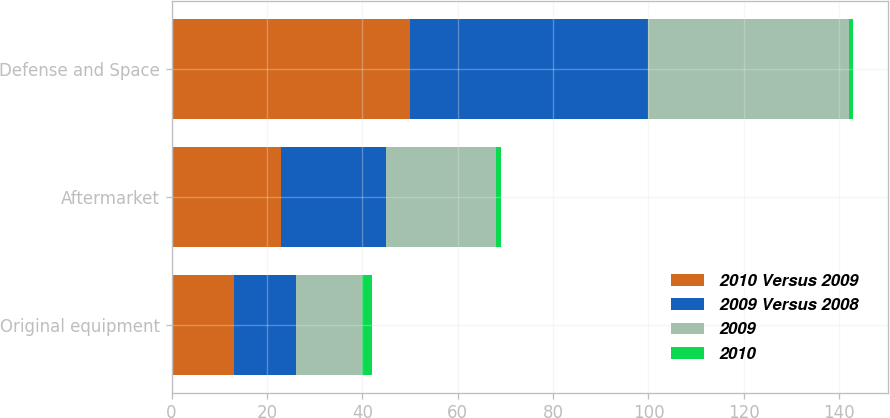Convert chart to OTSL. <chart><loc_0><loc_0><loc_500><loc_500><stacked_bar_chart><ecel><fcel>Original equipment<fcel>Aftermarket<fcel>Defense and Space<nl><fcel>2010 Versus 2009<fcel>13<fcel>23<fcel>50<nl><fcel>2009 Versus 2008<fcel>13<fcel>22<fcel>50<nl><fcel>2009<fcel>14<fcel>23<fcel>42<nl><fcel>2010<fcel>2<fcel>1<fcel>1<nl></chart> 